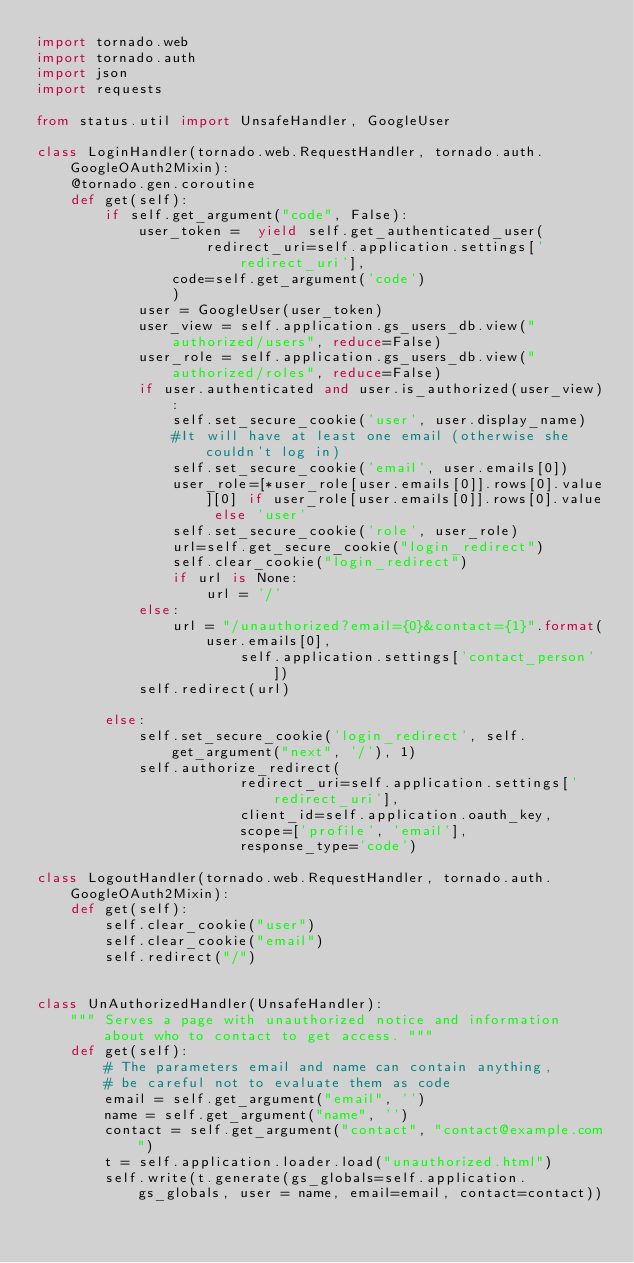<code> <loc_0><loc_0><loc_500><loc_500><_Python_>import tornado.web
import tornado.auth
import json
import requests

from status.util import UnsafeHandler, GoogleUser

class LoginHandler(tornado.web.RequestHandler, tornado.auth.GoogleOAuth2Mixin):
    @tornado.gen.coroutine
    def get(self):
        if self.get_argument("code", False):
            user_token =  yield self.get_authenticated_user(
                    redirect_uri=self.application.settings['redirect_uri'],
                code=self.get_argument('code')
                )
            user = GoogleUser(user_token)
            user_view = self.application.gs_users_db.view("authorized/users", reduce=False)
            user_role = self.application.gs_users_db.view("authorized/roles", reduce=False)
            if user.authenticated and user.is_authorized(user_view):
                self.set_secure_cookie('user', user.display_name)
                #It will have at least one email (otherwise she couldn't log in)
                self.set_secure_cookie('email', user.emails[0])
                user_role=[*user_role[user.emails[0]].rows[0].value][0] if user_role[user.emails[0]].rows[0].value else 'user'
                self.set_secure_cookie('role', user_role)
                url=self.get_secure_cookie("login_redirect")
                self.clear_cookie("login_redirect")
                if url is None:
                    url = '/'
            else:
                url = "/unauthorized?email={0}&contact={1}".format(user.emails[0],
                        self.application.settings['contact_person'])
            self.redirect(url)

        else:
            self.set_secure_cookie('login_redirect', self.get_argument("next", '/'), 1)
            self.authorize_redirect(
                        redirect_uri=self.application.settings['redirect_uri'],
                        client_id=self.application.oauth_key,
                        scope=['profile', 'email'],
                        response_type='code')

class LogoutHandler(tornado.web.RequestHandler, tornado.auth.GoogleOAuth2Mixin):
    def get(self):
        self.clear_cookie("user")
        self.clear_cookie("email")
        self.redirect("/")


class UnAuthorizedHandler(UnsafeHandler):
    """ Serves a page with unauthorized notice and information about who to contact to get access. """
    def get(self):
        # The parameters email and name can contain anything,
        # be careful not to evaluate them as code
        email = self.get_argument("email", '')
        name = self.get_argument("name", '')
        contact = self.get_argument("contact", "contact@example.com")
        t = self.application.loader.load("unauthorized.html")
        self.write(t.generate(gs_globals=self.application.gs_globals, user = name, email=email, contact=contact))
</code> 